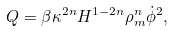<formula> <loc_0><loc_0><loc_500><loc_500>Q = \beta \kappa ^ { 2 n } H ^ { 1 - 2 n } \rho _ { m } ^ { n } \dot { \phi } ^ { 2 } ,</formula> 